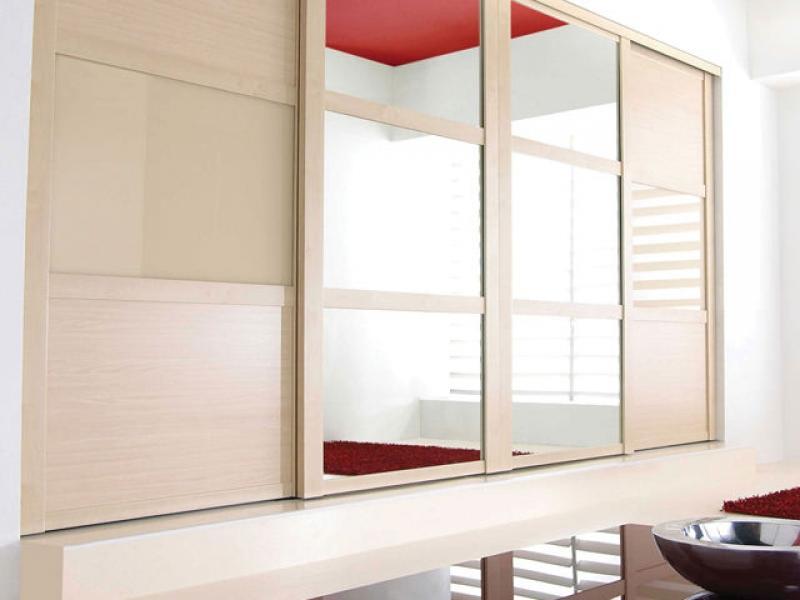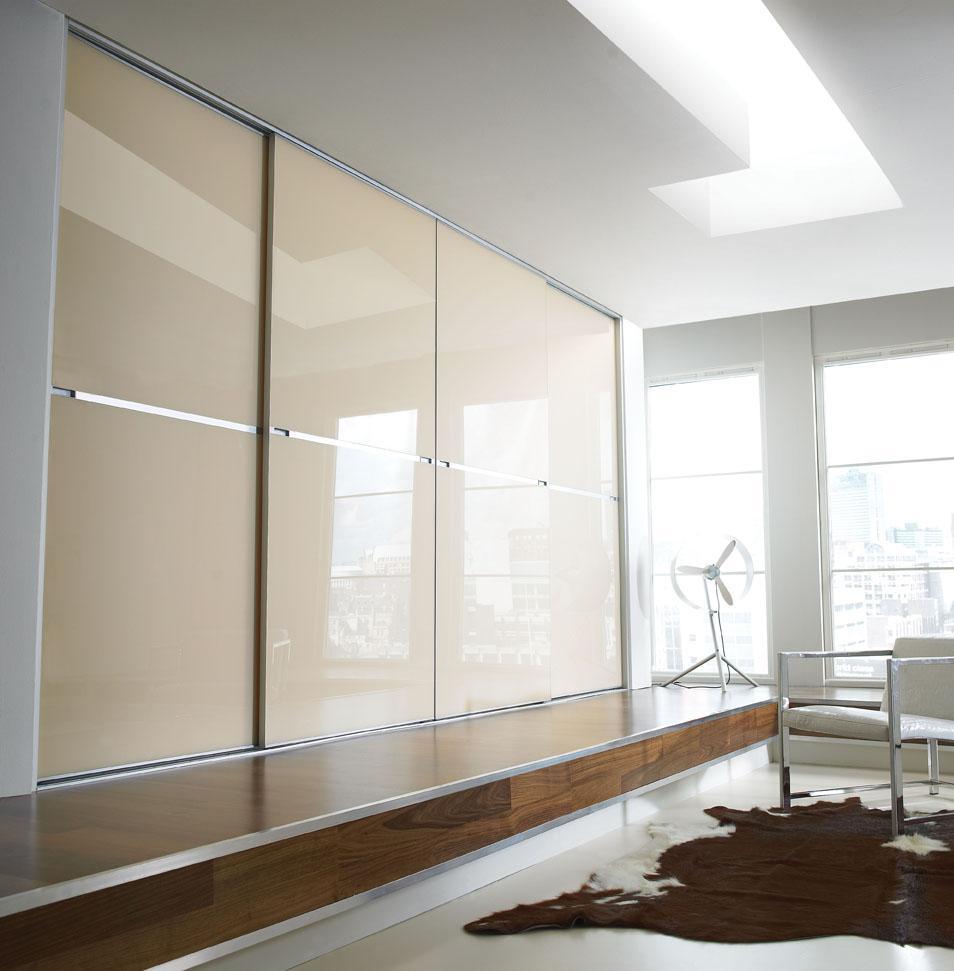The first image is the image on the left, the second image is the image on the right. Evaluate the accuracy of this statement regarding the images: "There are two closets with glass doors.". Is it true? Answer yes or no. Yes. The first image is the image on the left, the second image is the image on the right. For the images shown, is this caption "There is a chair in the image on the right." true? Answer yes or no. Yes. 